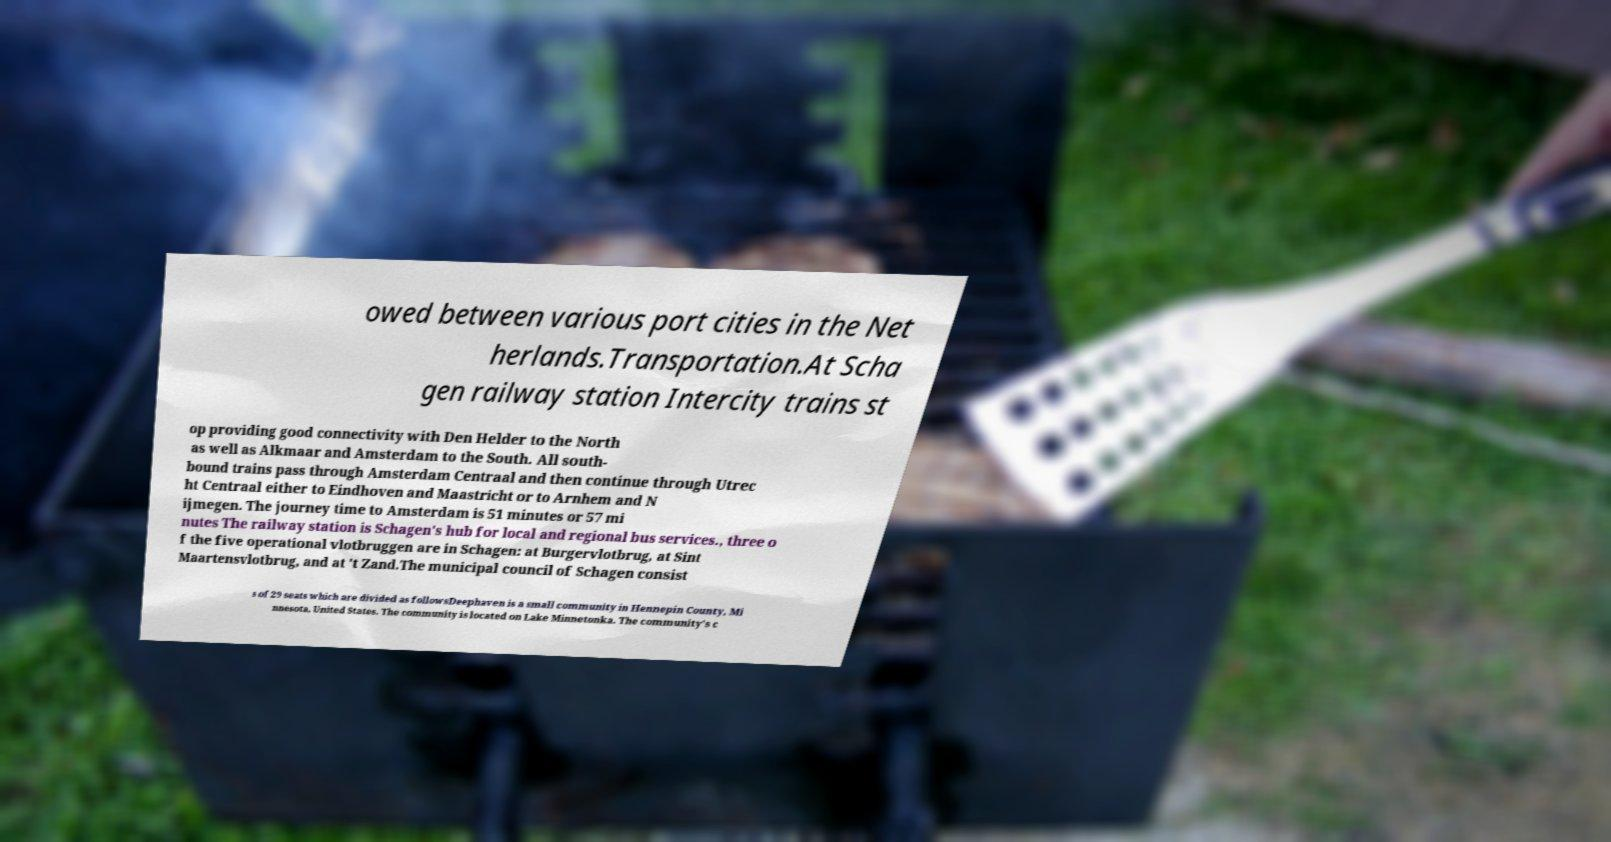Could you extract and type out the text from this image? owed between various port cities in the Net herlands.Transportation.At Scha gen railway station Intercity trains st op providing good connectivity with Den Helder to the North as well as Alkmaar and Amsterdam to the South. All south- bound trains pass through Amsterdam Centraal and then continue through Utrec ht Centraal either to Eindhoven and Maastricht or to Arnhem and N ijmegen. The journey time to Amsterdam is 51 minutes or 57 mi nutes The railway station is Schagen's hub for local and regional bus services., three o f the five operational vlotbruggen are in Schagen: at Burgervlotbrug, at Sint Maartensvlotbrug, and at 't Zand.The municipal council of Schagen consist s of 29 seats which are divided as followsDeephaven is a small community in Hennepin County, Mi nnesota, United States. The community is located on Lake Minnetonka. The community’s c 